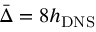<formula> <loc_0><loc_0><loc_500><loc_500>\bar { \Delta } = 8 h _ { D N S }</formula> 